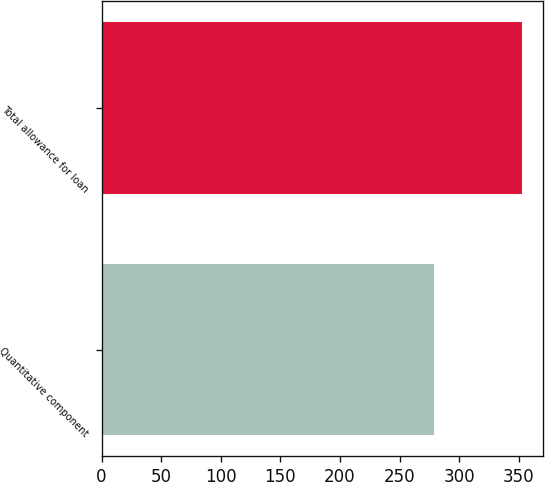Convert chart. <chart><loc_0><loc_0><loc_500><loc_500><bar_chart><fcel>Quantitative component<fcel>Total allowance for loan<nl><fcel>279<fcel>353<nl></chart> 